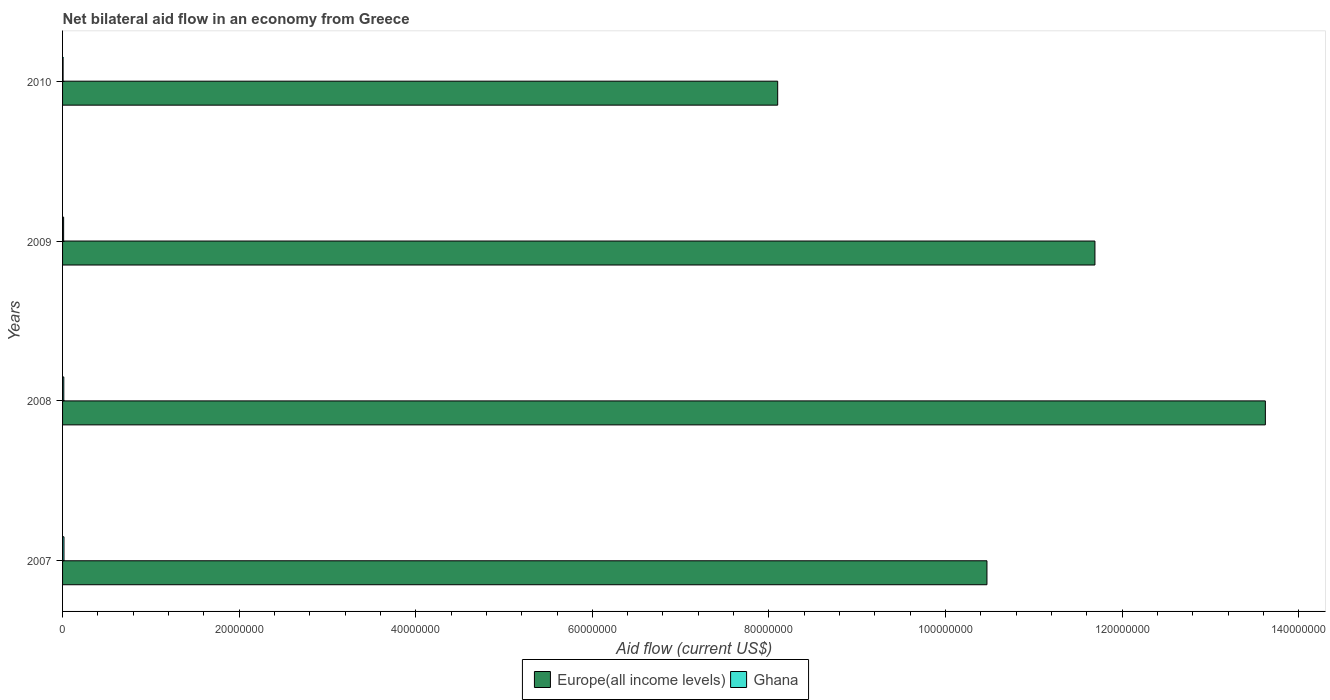How many different coloured bars are there?
Your answer should be compact. 2. How many groups of bars are there?
Offer a very short reply. 4. Are the number of bars on each tick of the Y-axis equal?
Offer a terse response. Yes. How many bars are there on the 4th tick from the bottom?
Ensure brevity in your answer.  2. What is the net bilateral aid flow in Europe(all income levels) in 2009?
Your answer should be very brief. 1.17e+08. Across all years, what is the maximum net bilateral aid flow in Europe(all income levels)?
Ensure brevity in your answer.  1.36e+08. What is the difference between the net bilateral aid flow in Europe(all income levels) in 2007 and that in 2010?
Ensure brevity in your answer.  2.37e+07. What is the difference between the net bilateral aid flow in Ghana in 2010 and the net bilateral aid flow in Europe(all income levels) in 2009?
Offer a very short reply. -1.17e+08. What is the average net bilateral aid flow in Europe(all income levels) per year?
Ensure brevity in your answer.  1.10e+08. In the year 2009, what is the difference between the net bilateral aid flow in Ghana and net bilateral aid flow in Europe(all income levels)?
Give a very brief answer. -1.17e+08. In how many years, is the net bilateral aid flow in Ghana greater than 52000000 US$?
Your answer should be very brief. 0. What is the ratio of the net bilateral aid flow in Ghana in 2008 to that in 2010?
Ensure brevity in your answer.  2.33. What is the difference between the highest and the second highest net bilateral aid flow in Europe(all income levels)?
Offer a terse response. 1.93e+07. What is the difference between the highest and the lowest net bilateral aid flow in Ghana?
Ensure brevity in your answer.  1.00e+05. In how many years, is the net bilateral aid flow in Europe(all income levels) greater than the average net bilateral aid flow in Europe(all income levels) taken over all years?
Keep it short and to the point. 2. Is the sum of the net bilateral aid flow in Europe(all income levels) in 2007 and 2010 greater than the maximum net bilateral aid flow in Ghana across all years?
Keep it short and to the point. Yes. What does the 2nd bar from the top in 2007 represents?
Give a very brief answer. Europe(all income levels). How many years are there in the graph?
Provide a short and direct response. 4. Does the graph contain any zero values?
Your answer should be very brief. No. Does the graph contain grids?
Ensure brevity in your answer.  No. How many legend labels are there?
Keep it short and to the point. 2. How are the legend labels stacked?
Give a very brief answer. Horizontal. What is the title of the graph?
Provide a short and direct response. Net bilateral aid flow in an economy from Greece. What is the Aid flow (current US$) in Europe(all income levels) in 2007?
Your answer should be very brief. 1.05e+08. What is the Aid flow (current US$) of Europe(all income levels) in 2008?
Offer a terse response. 1.36e+08. What is the Aid flow (current US$) of Ghana in 2008?
Your response must be concise. 1.40e+05. What is the Aid flow (current US$) in Europe(all income levels) in 2009?
Offer a terse response. 1.17e+08. What is the Aid flow (current US$) in Europe(all income levels) in 2010?
Make the answer very short. 8.10e+07. Across all years, what is the maximum Aid flow (current US$) of Europe(all income levels)?
Give a very brief answer. 1.36e+08. Across all years, what is the minimum Aid flow (current US$) of Europe(all income levels)?
Make the answer very short. 8.10e+07. Across all years, what is the minimum Aid flow (current US$) in Ghana?
Your answer should be very brief. 6.00e+04. What is the total Aid flow (current US$) of Europe(all income levels) in the graph?
Your response must be concise. 4.39e+08. What is the total Aid flow (current US$) of Ghana in the graph?
Ensure brevity in your answer.  4.80e+05. What is the difference between the Aid flow (current US$) in Europe(all income levels) in 2007 and that in 2008?
Ensure brevity in your answer.  -3.15e+07. What is the difference between the Aid flow (current US$) in Europe(all income levels) in 2007 and that in 2009?
Your answer should be very brief. -1.22e+07. What is the difference between the Aid flow (current US$) of Ghana in 2007 and that in 2009?
Your response must be concise. 4.00e+04. What is the difference between the Aid flow (current US$) in Europe(all income levels) in 2007 and that in 2010?
Keep it short and to the point. 2.37e+07. What is the difference between the Aid flow (current US$) of Ghana in 2007 and that in 2010?
Your answer should be very brief. 1.00e+05. What is the difference between the Aid flow (current US$) in Europe(all income levels) in 2008 and that in 2009?
Give a very brief answer. 1.93e+07. What is the difference between the Aid flow (current US$) in Ghana in 2008 and that in 2009?
Offer a very short reply. 2.00e+04. What is the difference between the Aid flow (current US$) of Europe(all income levels) in 2008 and that in 2010?
Keep it short and to the point. 5.52e+07. What is the difference between the Aid flow (current US$) of Ghana in 2008 and that in 2010?
Give a very brief answer. 8.00e+04. What is the difference between the Aid flow (current US$) in Europe(all income levels) in 2009 and that in 2010?
Make the answer very short. 3.59e+07. What is the difference between the Aid flow (current US$) of Europe(all income levels) in 2007 and the Aid flow (current US$) of Ghana in 2008?
Provide a succinct answer. 1.05e+08. What is the difference between the Aid flow (current US$) of Europe(all income levels) in 2007 and the Aid flow (current US$) of Ghana in 2009?
Make the answer very short. 1.05e+08. What is the difference between the Aid flow (current US$) of Europe(all income levels) in 2007 and the Aid flow (current US$) of Ghana in 2010?
Ensure brevity in your answer.  1.05e+08. What is the difference between the Aid flow (current US$) in Europe(all income levels) in 2008 and the Aid flow (current US$) in Ghana in 2009?
Your response must be concise. 1.36e+08. What is the difference between the Aid flow (current US$) of Europe(all income levels) in 2008 and the Aid flow (current US$) of Ghana in 2010?
Make the answer very short. 1.36e+08. What is the difference between the Aid flow (current US$) of Europe(all income levels) in 2009 and the Aid flow (current US$) of Ghana in 2010?
Your response must be concise. 1.17e+08. What is the average Aid flow (current US$) in Europe(all income levels) per year?
Offer a very short reply. 1.10e+08. What is the average Aid flow (current US$) in Ghana per year?
Provide a short and direct response. 1.20e+05. In the year 2007, what is the difference between the Aid flow (current US$) in Europe(all income levels) and Aid flow (current US$) in Ghana?
Provide a short and direct response. 1.05e+08. In the year 2008, what is the difference between the Aid flow (current US$) of Europe(all income levels) and Aid flow (current US$) of Ghana?
Ensure brevity in your answer.  1.36e+08. In the year 2009, what is the difference between the Aid flow (current US$) of Europe(all income levels) and Aid flow (current US$) of Ghana?
Give a very brief answer. 1.17e+08. In the year 2010, what is the difference between the Aid flow (current US$) in Europe(all income levels) and Aid flow (current US$) in Ghana?
Give a very brief answer. 8.09e+07. What is the ratio of the Aid flow (current US$) of Europe(all income levels) in 2007 to that in 2008?
Provide a short and direct response. 0.77. What is the ratio of the Aid flow (current US$) in Ghana in 2007 to that in 2008?
Keep it short and to the point. 1.14. What is the ratio of the Aid flow (current US$) of Europe(all income levels) in 2007 to that in 2009?
Ensure brevity in your answer.  0.9. What is the ratio of the Aid flow (current US$) of Europe(all income levels) in 2007 to that in 2010?
Provide a short and direct response. 1.29. What is the ratio of the Aid flow (current US$) of Ghana in 2007 to that in 2010?
Your response must be concise. 2.67. What is the ratio of the Aid flow (current US$) of Europe(all income levels) in 2008 to that in 2009?
Provide a succinct answer. 1.17. What is the ratio of the Aid flow (current US$) in Europe(all income levels) in 2008 to that in 2010?
Your answer should be very brief. 1.68. What is the ratio of the Aid flow (current US$) of Ghana in 2008 to that in 2010?
Ensure brevity in your answer.  2.33. What is the ratio of the Aid flow (current US$) in Europe(all income levels) in 2009 to that in 2010?
Keep it short and to the point. 1.44. What is the ratio of the Aid flow (current US$) of Ghana in 2009 to that in 2010?
Keep it short and to the point. 2. What is the difference between the highest and the second highest Aid flow (current US$) in Europe(all income levels)?
Offer a terse response. 1.93e+07. What is the difference between the highest and the second highest Aid flow (current US$) in Ghana?
Your response must be concise. 2.00e+04. What is the difference between the highest and the lowest Aid flow (current US$) of Europe(all income levels)?
Your answer should be compact. 5.52e+07. What is the difference between the highest and the lowest Aid flow (current US$) in Ghana?
Offer a terse response. 1.00e+05. 